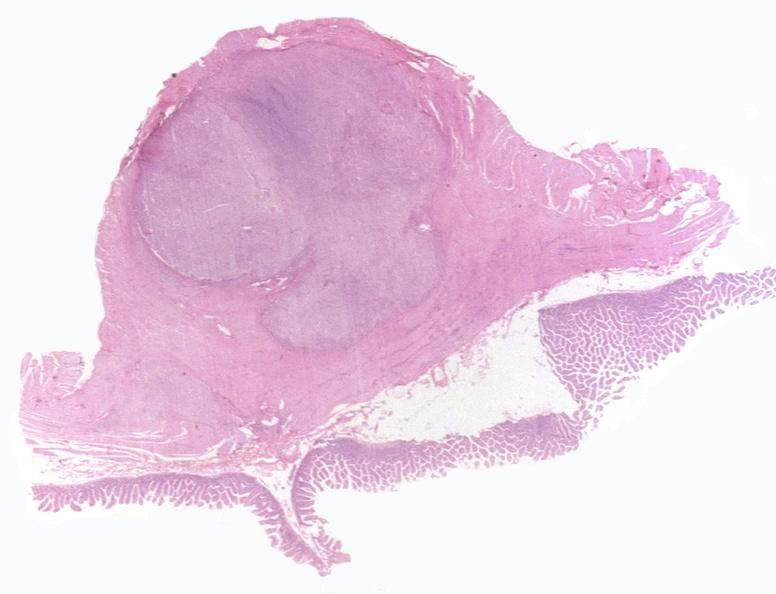what does this image show?
Answer the question using a single word or phrase. Intestine 